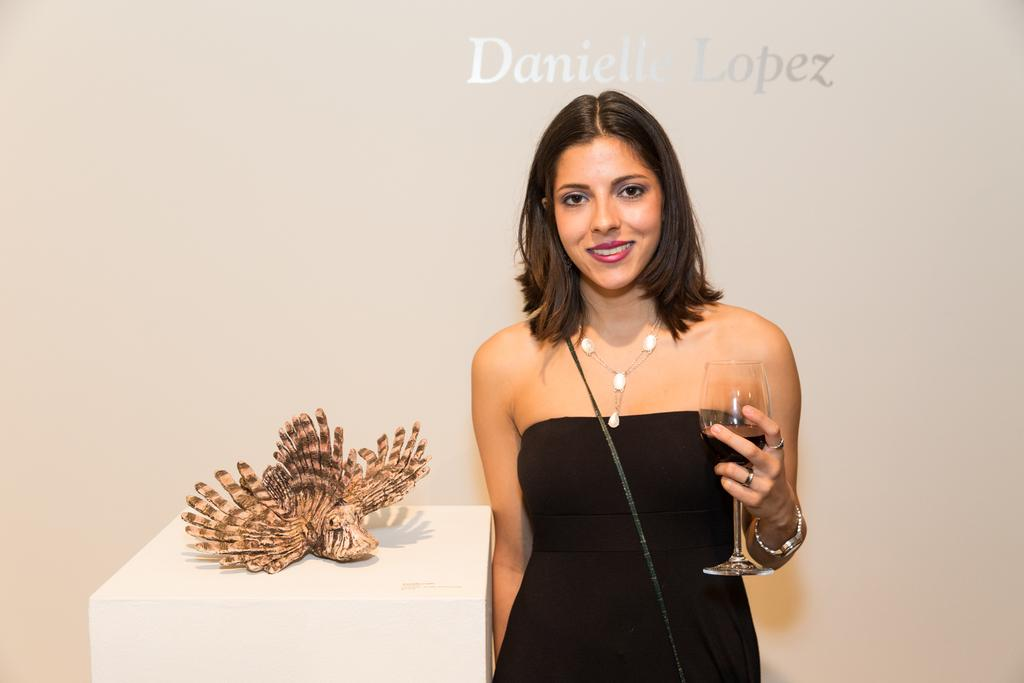Who is present in the image? There is a woman in the image. Where is the woman located in the image? The woman is standing on the right side. What is the woman holding in the image? The woman is holding a wine glass. What expression does the woman have in the image? The woman is smiling. What type of eye is visible on the woman's forehead in the image? There is no eye visible on the woman's forehead in the image. 